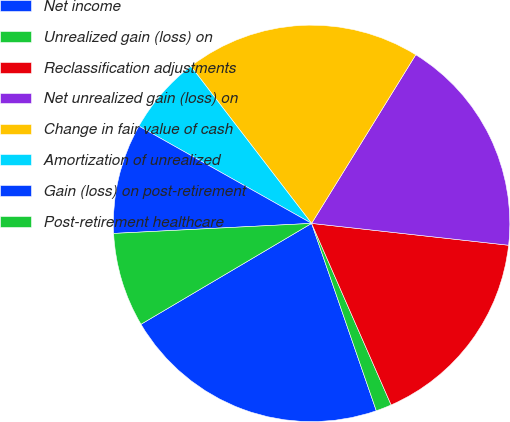<chart> <loc_0><loc_0><loc_500><loc_500><pie_chart><fcel>Net income<fcel>Unrealized gain (loss) on<fcel>Reclassification adjustments<fcel>Net unrealized gain (loss) on<fcel>Change in fair value of cash<fcel>Amortization of unrealized<fcel>Gain (loss) on post-retirement<fcel>Post-retirement healthcare<nl><fcel>21.79%<fcel>1.28%<fcel>16.67%<fcel>17.95%<fcel>19.23%<fcel>6.41%<fcel>8.97%<fcel>7.69%<nl></chart> 